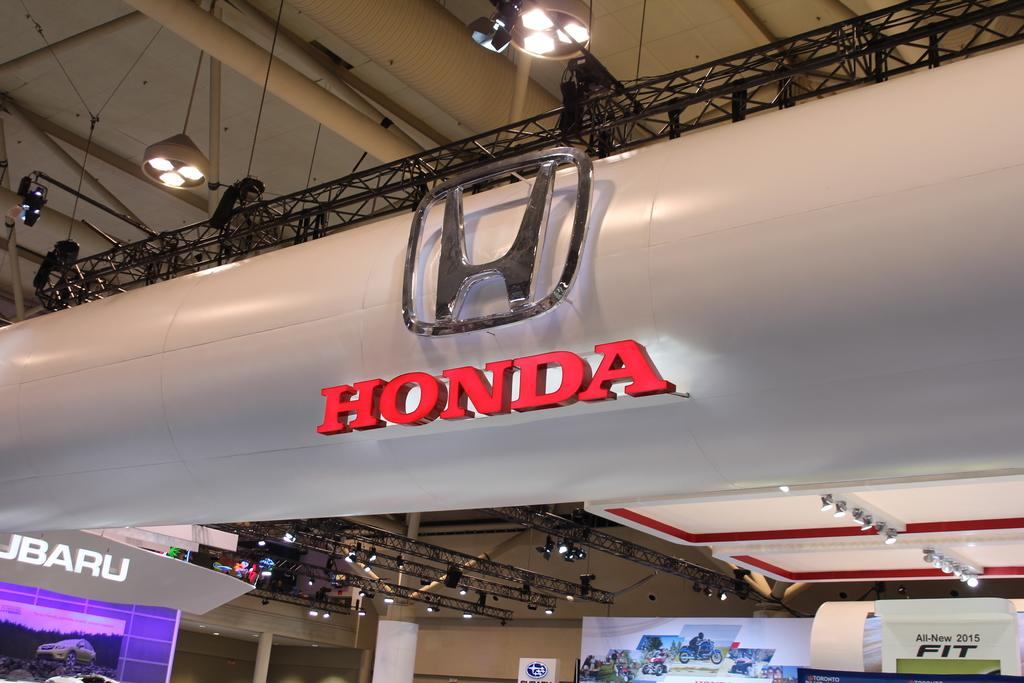<image>
Describe the image concisely. In a showroom, the Honda logo and Subaru logo are both evident. 